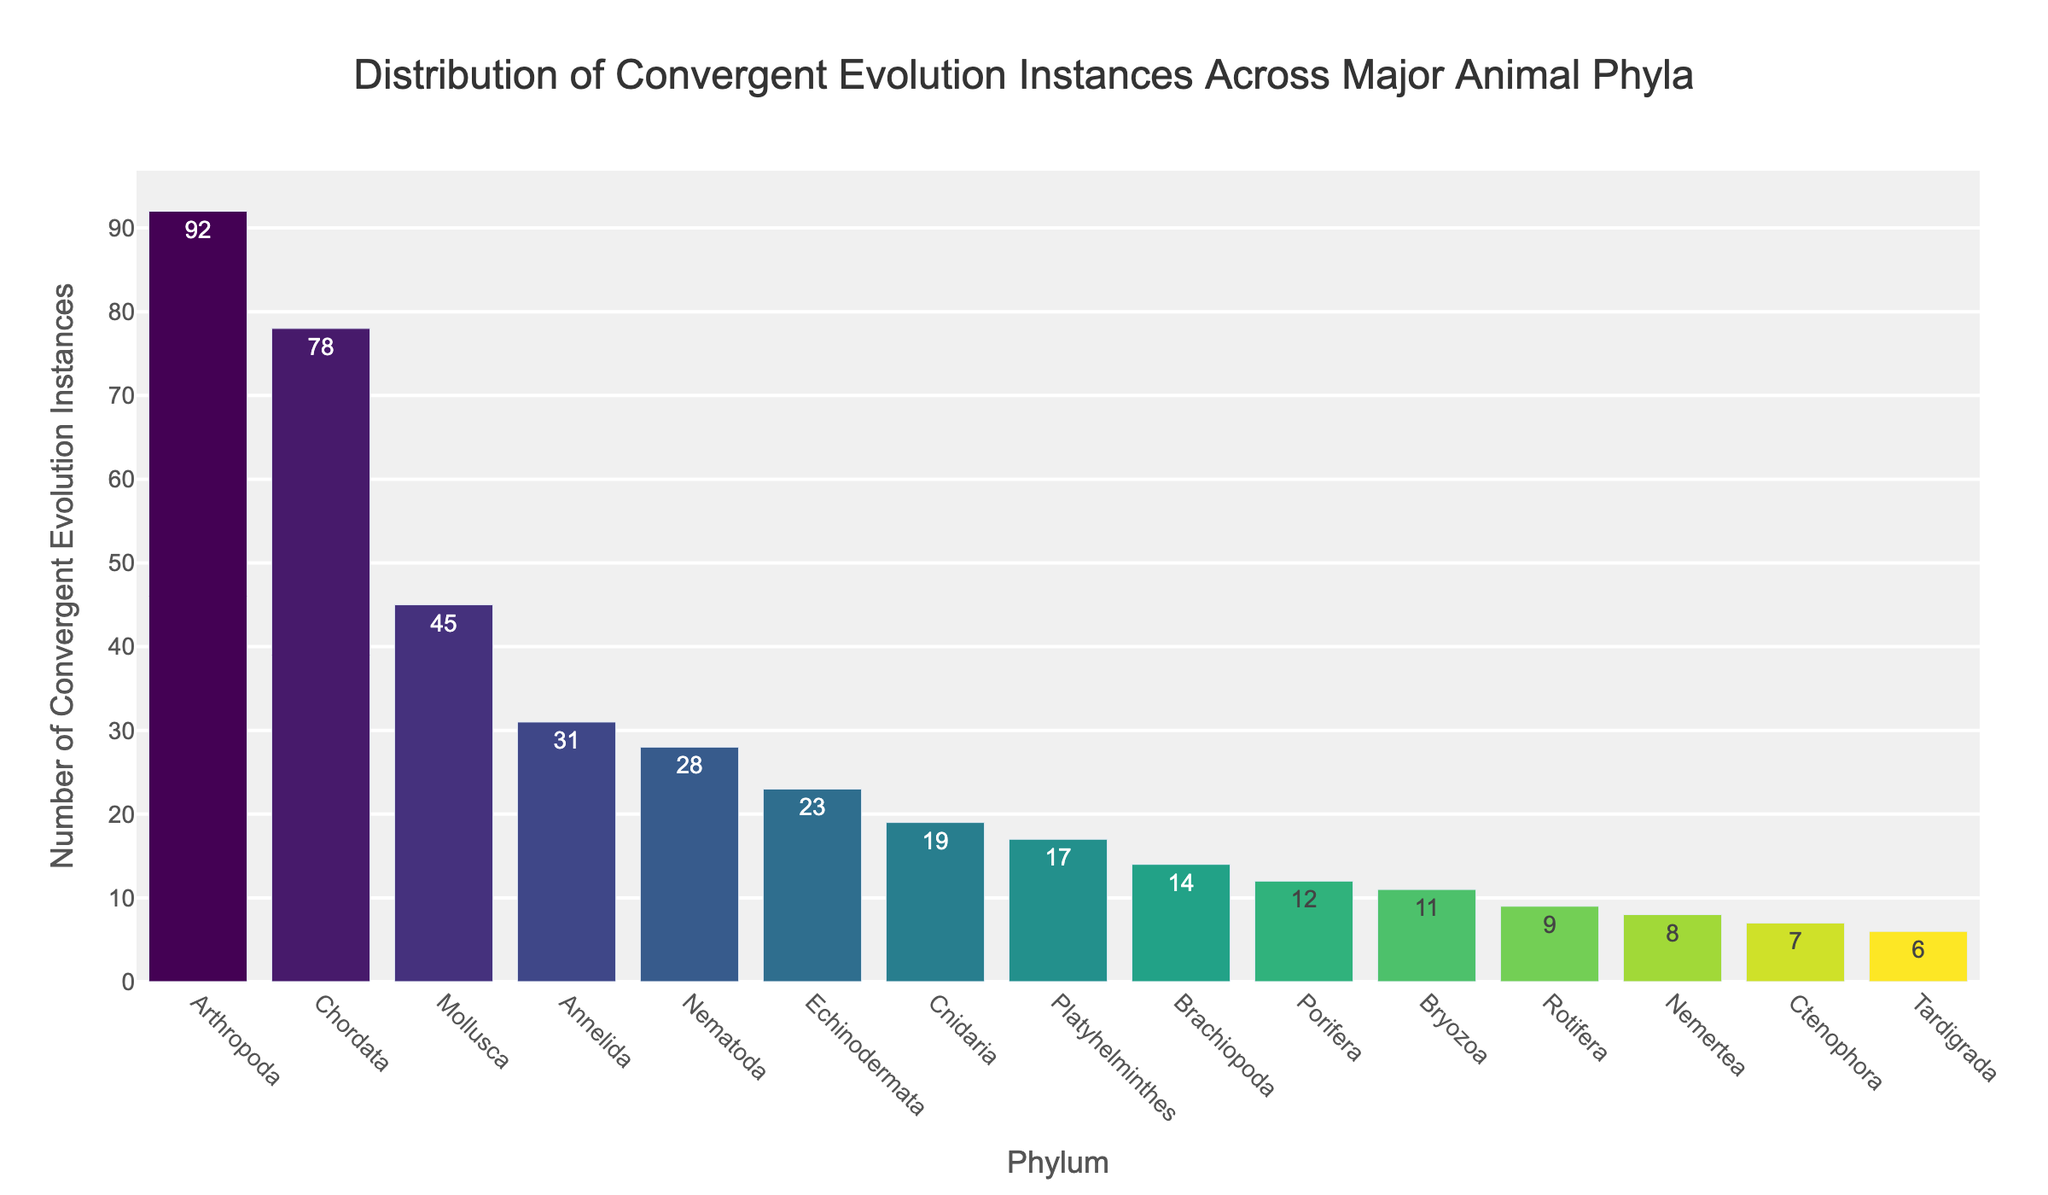Which phylum has the highest number of convergent evolution instances? To determine which phylum has the highest number of convergent evolution instances, look for the tallest bar in the chart. The tallest bar corresponds to Arthropoda with 92 instances.
Answer: Arthropoda What is the combined number of convergent evolution instances in Mollusca, Annelida, and Nematoda? Add the instances from each phylum: Mollusca (45) + Annelida (31) + Nematoda (28) = 45 + 31 + 28 = 104
Answer: 104 Is the number of convergent evolution instances in Chordata greater than the combined instances in Echinodermata and Platyhelminthes? First, add the instances from Echinodermata and Platyhelminthes: Echinodermata (23) + Platyhelminthes (17) = 40. Then compare this with the instances in Chordata (78). Since 78 > 40, Chordata has more instances.
Answer: Yes Which two phyla have the closest number of convergent evolution instances? Identify phyla with bars of similar height. Annelida (31) and Nematoda (28) have the closest numbers, with a difference of only 3 instances.
Answer: Annelida and Nematoda What is the average number of convergent evolution instances across all phyla? Sum all instances and divide by the number of phyla: (78 + 92 + 45 + 23 + 31 + 19 + 12 + 17 + 28 + 9 + 14 + 11 + 8 + 6 + 7) / 15 = 400 / 15 ≈ 26.67
Answer: 26.67 How does the height of the bar for Ctenophora compare to that of Porifera? The height of the bar for Ctenophora (7 instances) is lower than that for Porifera (12 instances).
Answer: Lower Among Cnidaria, Porifera, and Bryozoa, which phylum has the lowest number of convergent evolution instances? Compare the heights of the bars for these phyla. Cnidaria has 19 instances, Porifera has 12 instances, and Bryozoa has 11 instances. Therefore, Bryozoa has the lowest number.
Answer: Bryozoa What is the total number of convergent evolution instances in phyla with less than 10 instances? Identify phyla with less than 10 instances: Rotifera (9), Nemertea (8), Tardigrada (6), and Ctenophora (7). Sum these instances: 9 + 8 + 6 + 7 = 30
Answer: 30 